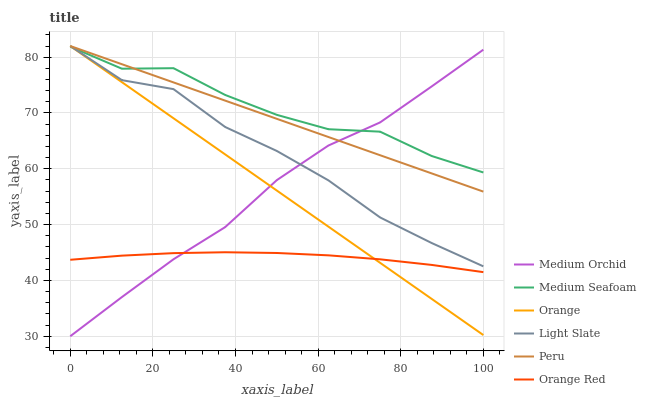Does Medium Orchid have the minimum area under the curve?
Answer yes or no. No. Does Medium Orchid have the maximum area under the curve?
Answer yes or no. No. Is Medium Orchid the smoothest?
Answer yes or no. No. Is Medium Orchid the roughest?
Answer yes or no. No. Does Orange Red have the lowest value?
Answer yes or no. No. Does Medium Orchid have the highest value?
Answer yes or no. No. Is Orange Red less than Light Slate?
Answer yes or no. Yes. Is Medium Seafoam greater than Orange Red?
Answer yes or no. Yes. Does Orange Red intersect Light Slate?
Answer yes or no. No. 